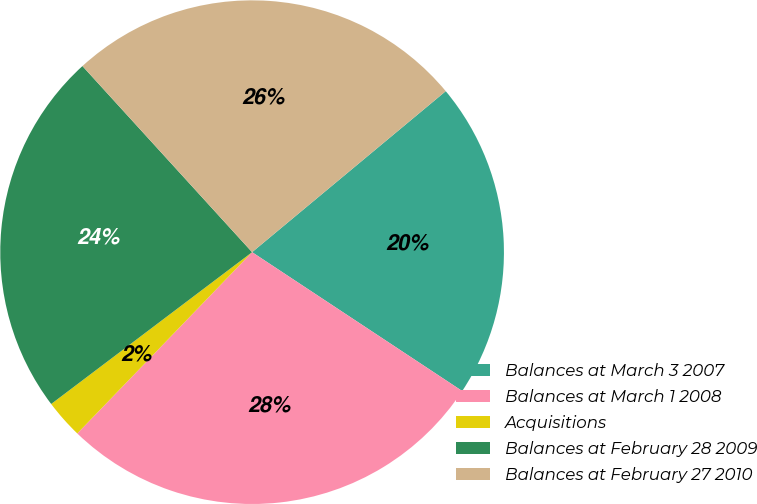<chart> <loc_0><loc_0><loc_500><loc_500><pie_chart><fcel>Balances at March 3 2007<fcel>Balances at March 1 2008<fcel>Acquisitions<fcel>Balances at February 28 2009<fcel>Balances at February 27 2010<nl><fcel>20.33%<fcel>27.91%<fcel>2.49%<fcel>23.53%<fcel>25.72%<nl></chart> 